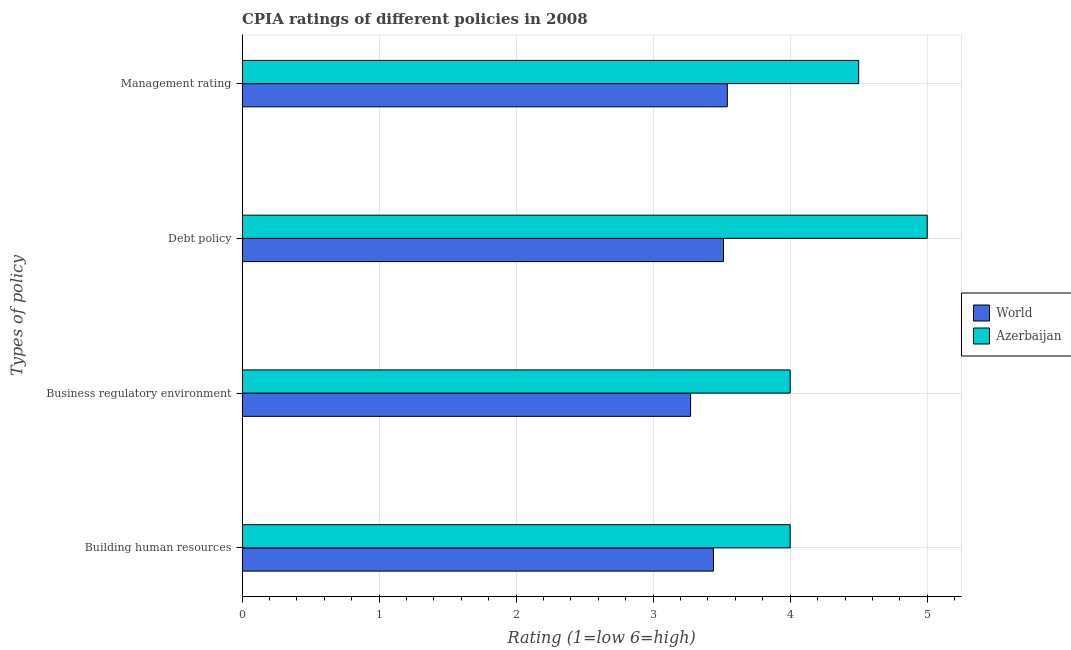Are the number of bars per tick equal to the number of legend labels?
Your response must be concise. Yes. How many bars are there on the 3rd tick from the top?
Keep it short and to the point. 2. How many bars are there on the 3rd tick from the bottom?
Make the answer very short. 2. What is the label of the 4th group of bars from the top?
Offer a very short reply. Building human resources. What is the cpia rating of building human resources in Azerbaijan?
Make the answer very short. 4. Across all countries, what is the maximum cpia rating of management?
Your response must be concise. 4.5. Across all countries, what is the minimum cpia rating of management?
Give a very brief answer. 3.54. In which country was the cpia rating of building human resources maximum?
Ensure brevity in your answer.  Azerbaijan. What is the total cpia rating of management in the graph?
Provide a succinct answer. 8.04. What is the difference between the cpia rating of management in World and that in Azerbaijan?
Make the answer very short. -0.96. What is the difference between the cpia rating of debt policy in World and the cpia rating of building human resources in Azerbaijan?
Keep it short and to the point. -0.49. What is the average cpia rating of building human resources per country?
Give a very brief answer. 3.72. In how many countries, is the cpia rating of management greater than 3.8 ?
Your answer should be compact. 1. What is the ratio of the cpia rating of building human resources in Azerbaijan to that in World?
Offer a terse response. 1.16. Is the difference between the cpia rating of management in World and Azerbaijan greater than the difference between the cpia rating of business regulatory environment in World and Azerbaijan?
Your response must be concise. No. What is the difference between the highest and the second highest cpia rating of debt policy?
Your answer should be compact. 1.49. What is the difference between the highest and the lowest cpia rating of building human resources?
Make the answer very short. 0.56. In how many countries, is the cpia rating of business regulatory environment greater than the average cpia rating of business regulatory environment taken over all countries?
Provide a succinct answer. 1. Is the sum of the cpia rating of debt policy in World and Azerbaijan greater than the maximum cpia rating of management across all countries?
Provide a short and direct response. Yes. What does the 2nd bar from the top in Debt policy represents?
Offer a very short reply. World. What does the 2nd bar from the bottom in Debt policy represents?
Offer a terse response. Azerbaijan. Is it the case that in every country, the sum of the cpia rating of building human resources and cpia rating of business regulatory environment is greater than the cpia rating of debt policy?
Ensure brevity in your answer.  Yes. Are all the bars in the graph horizontal?
Your answer should be compact. Yes. How many countries are there in the graph?
Provide a short and direct response. 2. Are the values on the major ticks of X-axis written in scientific E-notation?
Offer a terse response. No. Does the graph contain any zero values?
Your answer should be compact. No. How many legend labels are there?
Offer a very short reply. 2. What is the title of the graph?
Your answer should be compact. CPIA ratings of different policies in 2008. What is the label or title of the X-axis?
Offer a very short reply. Rating (1=low 6=high). What is the label or title of the Y-axis?
Keep it short and to the point. Types of policy. What is the Rating (1=low 6=high) of World in Building human resources?
Keep it short and to the point. 3.44. What is the Rating (1=low 6=high) of World in Business regulatory environment?
Provide a succinct answer. 3.27. What is the Rating (1=low 6=high) of World in Debt policy?
Offer a terse response. 3.51. What is the Rating (1=low 6=high) in Azerbaijan in Debt policy?
Offer a terse response. 5. What is the Rating (1=low 6=high) in World in Management rating?
Keep it short and to the point. 3.54. Across all Types of policy, what is the maximum Rating (1=low 6=high) of World?
Provide a succinct answer. 3.54. Across all Types of policy, what is the maximum Rating (1=low 6=high) in Azerbaijan?
Offer a very short reply. 5. Across all Types of policy, what is the minimum Rating (1=low 6=high) in World?
Offer a terse response. 3.27. Across all Types of policy, what is the minimum Rating (1=low 6=high) of Azerbaijan?
Offer a very short reply. 4. What is the total Rating (1=low 6=high) of World in the graph?
Provide a succinct answer. 13.77. What is the difference between the Rating (1=low 6=high) of World in Building human resources and that in Business regulatory environment?
Offer a terse response. 0.17. What is the difference between the Rating (1=low 6=high) in Azerbaijan in Building human resources and that in Business regulatory environment?
Keep it short and to the point. 0. What is the difference between the Rating (1=low 6=high) in World in Building human resources and that in Debt policy?
Provide a short and direct response. -0.07. What is the difference between the Rating (1=low 6=high) of World in Building human resources and that in Management rating?
Offer a terse response. -0.1. What is the difference between the Rating (1=low 6=high) in World in Business regulatory environment and that in Debt policy?
Give a very brief answer. -0.24. What is the difference between the Rating (1=low 6=high) of World in Business regulatory environment and that in Management rating?
Give a very brief answer. -0.27. What is the difference between the Rating (1=low 6=high) in World in Debt policy and that in Management rating?
Your answer should be compact. -0.03. What is the difference between the Rating (1=low 6=high) of Azerbaijan in Debt policy and that in Management rating?
Provide a short and direct response. 0.5. What is the difference between the Rating (1=low 6=high) in World in Building human resources and the Rating (1=low 6=high) in Azerbaijan in Business regulatory environment?
Provide a succinct answer. -0.56. What is the difference between the Rating (1=low 6=high) of World in Building human resources and the Rating (1=low 6=high) of Azerbaijan in Debt policy?
Keep it short and to the point. -1.56. What is the difference between the Rating (1=low 6=high) of World in Building human resources and the Rating (1=low 6=high) of Azerbaijan in Management rating?
Make the answer very short. -1.06. What is the difference between the Rating (1=low 6=high) in World in Business regulatory environment and the Rating (1=low 6=high) in Azerbaijan in Debt policy?
Provide a succinct answer. -1.73. What is the difference between the Rating (1=low 6=high) of World in Business regulatory environment and the Rating (1=low 6=high) of Azerbaijan in Management rating?
Make the answer very short. -1.23. What is the difference between the Rating (1=low 6=high) of World in Debt policy and the Rating (1=low 6=high) of Azerbaijan in Management rating?
Give a very brief answer. -0.99. What is the average Rating (1=low 6=high) in World per Types of policy?
Offer a terse response. 3.44. What is the average Rating (1=low 6=high) in Azerbaijan per Types of policy?
Keep it short and to the point. 4.38. What is the difference between the Rating (1=low 6=high) of World and Rating (1=low 6=high) of Azerbaijan in Building human resources?
Your response must be concise. -0.56. What is the difference between the Rating (1=low 6=high) in World and Rating (1=low 6=high) in Azerbaijan in Business regulatory environment?
Your answer should be very brief. -0.73. What is the difference between the Rating (1=low 6=high) of World and Rating (1=low 6=high) of Azerbaijan in Debt policy?
Your response must be concise. -1.49. What is the difference between the Rating (1=low 6=high) in World and Rating (1=low 6=high) in Azerbaijan in Management rating?
Your answer should be compact. -0.96. What is the ratio of the Rating (1=low 6=high) of World in Building human resources to that in Business regulatory environment?
Make the answer very short. 1.05. What is the ratio of the Rating (1=low 6=high) in World in Building human resources to that in Debt policy?
Provide a short and direct response. 0.98. What is the ratio of the Rating (1=low 6=high) in World in Building human resources to that in Management rating?
Ensure brevity in your answer.  0.97. What is the ratio of the Rating (1=low 6=high) in World in Business regulatory environment to that in Debt policy?
Make the answer very short. 0.93. What is the ratio of the Rating (1=low 6=high) of Azerbaijan in Business regulatory environment to that in Debt policy?
Ensure brevity in your answer.  0.8. What is the ratio of the Rating (1=low 6=high) in World in Business regulatory environment to that in Management rating?
Give a very brief answer. 0.92. What is the ratio of the Rating (1=low 6=high) of World in Debt policy to that in Management rating?
Offer a very short reply. 0.99. What is the difference between the highest and the second highest Rating (1=low 6=high) in World?
Provide a short and direct response. 0.03. What is the difference between the highest and the lowest Rating (1=low 6=high) in World?
Provide a succinct answer. 0.27. 